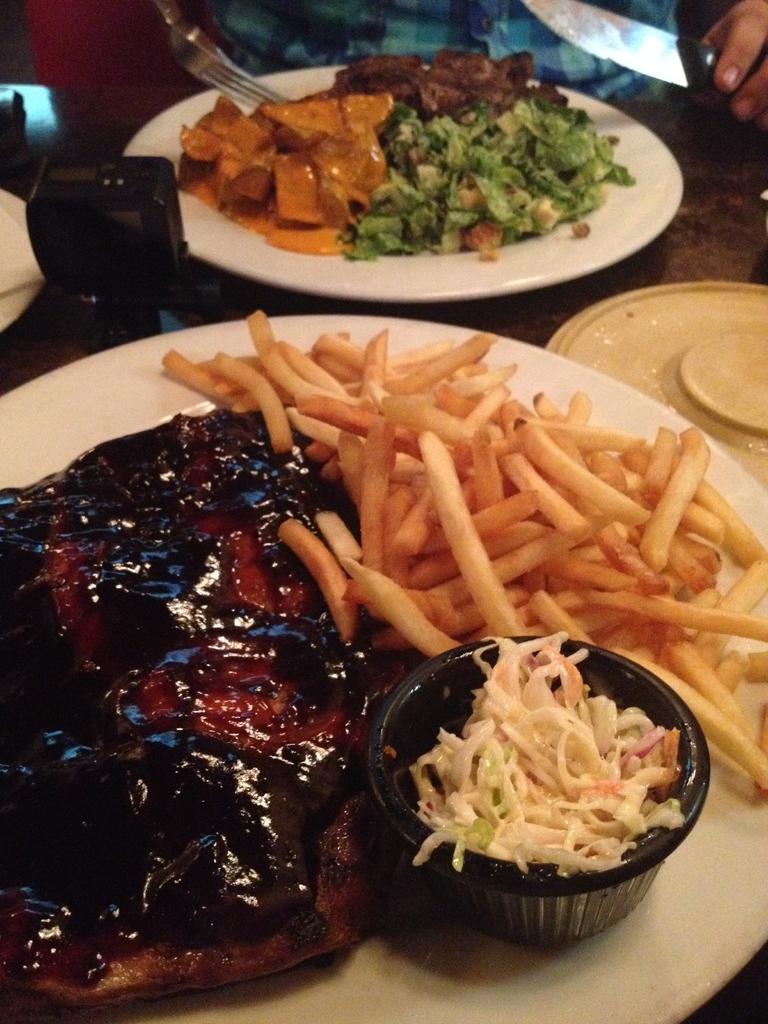In one or two sentences, can you explain what this image depicts? In this image we can see some person holding the knife. We can also see the plates of food items. We can also see a bowl of food. Image also consists of some other objects on the table. 